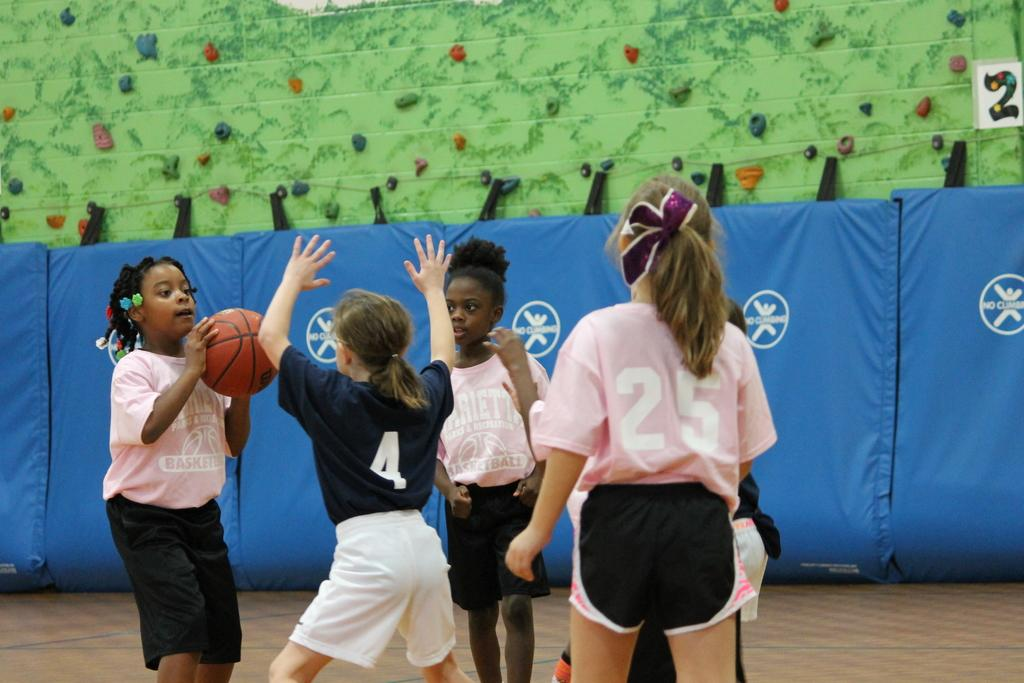What are the people in the image doing? The people in the image are on the ground. What is the girl holding in the image? The girl is holding a ball in the image. What can be seen in the background of the image? There are curtains and objects visible in the background of the image. What type of dinner is being served in the image? There is no dinner present in the image. What action is the plough performing in the image? There is no plough present in the image. 